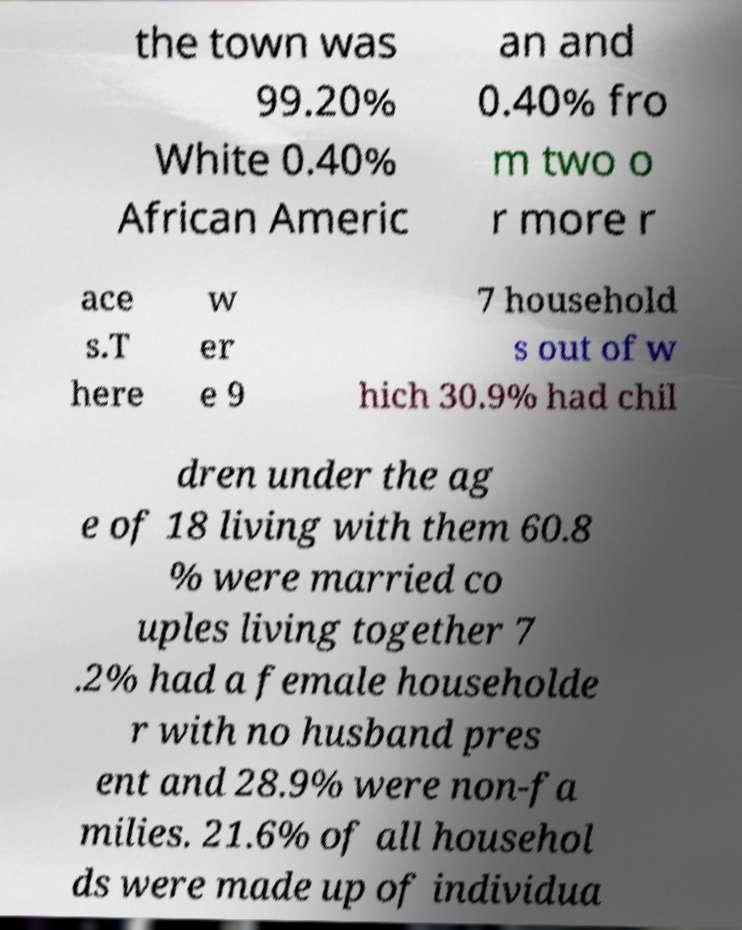I need the written content from this picture converted into text. Can you do that? the town was 99.20% White 0.40% African Americ an and 0.40% fro m two o r more r ace s.T here w er e 9 7 household s out of w hich 30.9% had chil dren under the ag e of 18 living with them 60.8 % were married co uples living together 7 .2% had a female householde r with no husband pres ent and 28.9% were non-fa milies. 21.6% of all househol ds were made up of individua 